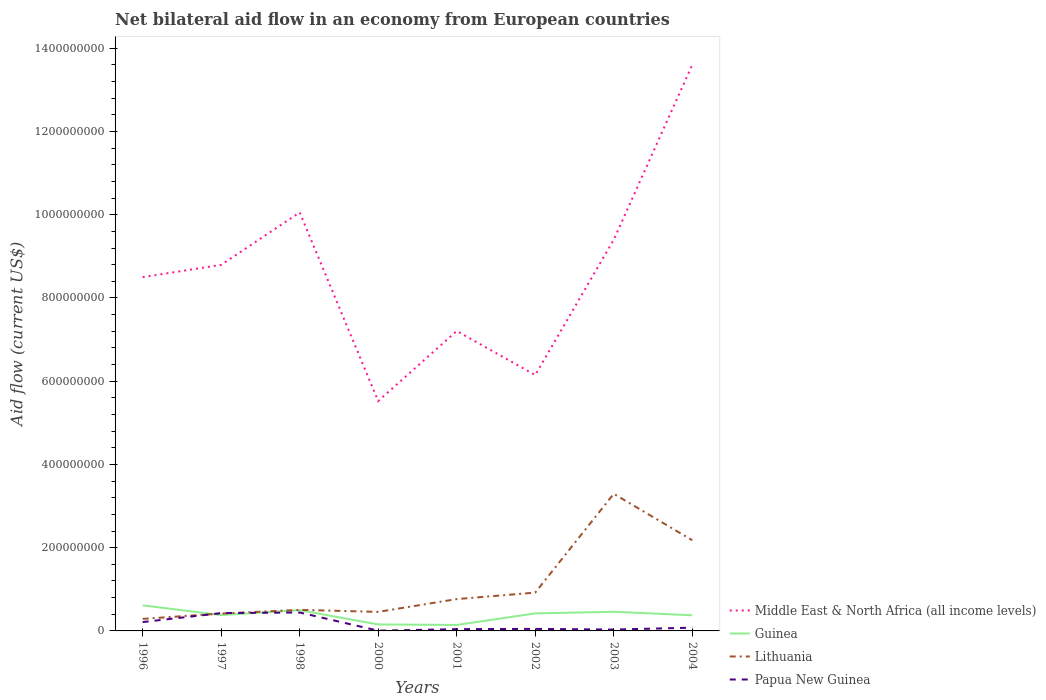Does the line corresponding to Middle East & North Africa (all income levels) intersect with the line corresponding to Guinea?
Give a very brief answer. No. Across all years, what is the maximum net bilateral aid flow in Lithuania?
Offer a terse response. 2.89e+07. What is the total net bilateral aid flow in Guinea in the graph?
Your answer should be compact. -2.20e+07. What is the difference between the highest and the second highest net bilateral aid flow in Middle East & North Africa (all income levels)?
Offer a terse response. 8.08e+08. What is the difference between the highest and the lowest net bilateral aid flow in Papua New Guinea?
Keep it short and to the point. 3. What is the difference between two consecutive major ticks on the Y-axis?
Offer a very short reply. 2.00e+08. Does the graph contain any zero values?
Keep it short and to the point. No. Does the graph contain grids?
Your answer should be compact. No. Where does the legend appear in the graph?
Give a very brief answer. Bottom right. What is the title of the graph?
Provide a succinct answer. Net bilateral aid flow in an economy from European countries. Does "Syrian Arab Republic" appear as one of the legend labels in the graph?
Ensure brevity in your answer.  No. What is the label or title of the X-axis?
Provide a short and direct response. Years. What is the Aid flow (current US$) of Middle East & North Africa (all income levels) in 1996?
Provide a short and direct response. 8.50e+08. What is the Aid flow (current US$) in Guinea in 1996?
Your response must be concise. 6.15e+07. What is the Aid flow (current US$) in Lithuania in 1996?
Offer a terse response. 2.89e+07. What is the Aid flow (current US$) of Papua New Guinea in 1996?
Ensure brevity in your answer.  2.13e+07. What is the Aid flow (current US$) of Middle East & North Africa (all income levels) in 1997?
Offer a very short reply. 8.79e+08. What is the Aid flow (current US$) in Guinea in 1997?
Your answer should be very brief. 3.81e+07. What is the Aid flow (current US$) of Lithuania in 1997?
Provide a short and direct response. 4.17e+07. What is the Aid flow (current US$) of Papua New Guinea in 1997?
Offer a terse response. 4.28e+07. What is the Aid flow (current US$) in Middle East & North Africa (all income levels) in 1998?
Keep it short and to the point. 1.01e+09. What is the Aid flow (current US$) of Guinea in 1998?
Provide a short and direct response. 4.98e+07. What is the Aid flow (current US$) in Lithuania in 1998?
Provide a short and direct response. 5.06e+07. What is the Aid flow (current US$) in Papua New Guinea in 1998?
Provide a short and direct response. 4.43e+07. What is the Aid flow (current US$) in Middle East & North Africa (all income levels) in 2000?
Your answer should be very brief. 5.52e+08. What is the Aid flow (current US$) in Guinea in 2000?
Your response must be concise. 1.56e+07. What is the Aid flow (current US$) of Lithuania in 2000?
Make the answer very short. 4.57e+07. What is the Aid flow (current US$) in Papua New Guinea in 2000?
Your response must be concise. 5.70e+05. What is the Aid flow (current US$) in Middle East & North Africa (all income levels) in 2001?
Give a very brief answer. 7.21e+08. What is the Aid flow (current US$) in Guinea in 2001?
Your answer should be compact. 1.43e+07. What is the Aid flow (current US$) in Lithuania in 2001?
Your answer should be compact. 7.64e+07. What is the Aid flow (current US$) of Papua New Guinea in 2001?
Your response must be concise. 4.30e+06. What is the Aid flow (current US$) in Middle East & North Africa (all income levels) in 2002?
Keep it short and to the point. 6.15e+08. What is the Aid flow (current US$) of Guinea in 2002?
Ensure brevity in your answer.  4.22e+07. What is the Aid flow (current US$) of Lithuania in 2002?
Ensure brevity in your answer.  9.21e+07. What is the Aid flow (current US$) in Papua New Guinea in 2002?
Keep it short and to the point. 4.86e+06. What is the Aid flow (current US$) in Middle East & North Africa (all income levels) in 2003?
Your answer should be compact. 9.40e+08. What is the Aid flow (current US$) of Guinea in 2003?
Give a very brief answer. 4.60e+07. What is the Aid flow (current US$) in Lithuania in 2003?
Give a very brief answer. 3.29e+08. What is the Aid flow (current US$) of Papua New Guinea in 2003?
Provide a succinct answer. 3.27e+06. What is the Aid flow (current US$) of Middle East & North Africa (all income levels) in 2004?
Give a very brief answer. 1.36e+09. What is the Aid flow (current US$) of Guinea in 2004?
Your response must be concise. 3.76e+07. What is the Aid flow (current US$) in Lithuania in 2004?
Offer a terse response. 2.18e+08. What is the Aid flow (current US$) of Papua New Guinea in 2004?
Provide a short and direct response. 7.80e+06. Across all years, what is the maximum Aid flow (current US$) in Middle East & North Africa (all income levels)?
Offer a terse response. 1.36e+09. Across all years, what is the maximum Aid flow (current US$) in Guinea?
Give a very brief answer. 6.15e+07. Across all years, what is the maximum Aid flow (current US$) of Lithuania?
Offer a terse response. 3.29e+08. Across all years, what is the maximum Aid flow (current US$) of Papua New Guinea?
Provide a succinct answer. 4.43e+07. Across all years, what is the minimum Aid flow (current US$) in Middle East & North Africa (all income levels)?
Your response must be concise. 5.52e+08. Across all years, what is the minimum Aid flow (current US$) in Guinea?
Provide a short and direct response. 1.43e+07. Across all years, what is the minimum Aid flow (current US$) in Lithuania?
Offer a very short reply. 2.89e+07. Across all years, what is the minimum Aid flow (current US$) of Papua New Guinea?
Your answer should be very brief. 5.70e+05. What is the total Aid flow (current US$) in Middle East & North Africa (all income levels) in the graph?
Make the answer very short. 6.92e+09. What is the total Aid flow (current US$) in Guinea in the graph?
Provide a succinct answer. 3.05e+08. What is the total Aid flow (current US$) of Lithuania in the graph?
Provide a succinct answer. 8.83e+08. What is the total Aid flow (current US$) in Papua New Guinea in the graph?
Your answer should be very brief. 1.29e+08. What is the difference between the Aid flow (current US$) in Middle East & North Africa (all income levels) in 1996 and that in 1997?
Ensure brevity in your answer.  -2.94e+07. What is the difference between the Aid flow (current US$) of Guinea in 1996 and that in 1997?
Ensure brevity in your answer.  2.34e+07. What is the difference between the Aid flow (current US$) of Lithuania in 1996 and that in 1997?
Provide a succinct answer. -1.28e+07. What is the difference between the Aid flow (current US$) of Papua New Guinea in 1996 and that in 1997?
Your answer should be compact. -2.15e+07. What is the difference between the Aid flow (current US$) in Middle East & North Africa (all income levels) in 1996 and that in 1998?
Ensure brevity in your answer.  -1.55e+08. What is the difference between the Aid flow (current US$) in Guinea in 1996 and that in 1998?
Provide a short and direct response. 1.17e+07. What is the difference between the Aid flow (current US$) in Lithuania in 1996 and that in 1998?
Your answer should be very brief. -2.17e+07. What is the difference between the Aid flow (current US$) of Papua New Guinea in 1996 and that in 1998?
Provide a succinct answer. -2.30e+07. What is the difference between the Aid flow (current US$) of Middle East & North Africa (all income levels) in 1996 and that in 2000?
Ensure brevity in your answer.  2.98e+08. What is the difference between the Aid flow (current US$) in Guinea in 1996 and that in 2000?
Make the answer very short. 4.59e+07. What is the difference between the Aid flow (current US$) in Lithuania in 1996 and that in 2000?
Provide a succinct answer. -1.68e+07. What is the difference between the Aid flow (current US$) of Papua New Guinea in 1996 and that in 2000?
Your response must be concise. 2.07e+07. What is the difference between the Aid flow (current US$) in Middle East & North Africa (all income levels) in 1996 and that in 2001?
Offer a very short reply. 1.29e+08. What is the difference between the Aid flow (current US$) in Guinea in 1996 and that in 2001?
Provide a short and direct response. 4.72e+07. What is the difference between the Aid flow (current US$) of Lithuania in 1996 and that in 2001?
Your response must be concise. -4.75e+07. What is the difference between the Aid flow (current US$) in Papua New Guinea in 1996 and that in 2001?
Your answer should be compact. 1.70e+07. What is the difference between the Aid flow (current US$) in Middle East & North Africa (all income levels) in 1996 and that in 2002?
Offer a very short reply. 2.35e+08. What is the difference between the Aid flow (current US$) in Guinea in 1996 and that in 2002?
Ensure brevity in your answer.  1.93e+07. What is the difference between the Aid flow (current US$) in Lithuania in 1996 and that in 2002?
Keep it short and to the point. -6.32e+07. What is the difference between the Aid flow (current US$) in Papua New Guinea in 1996 and that in 2002?
Ensure brevity in your answer.  1.64e+07. What is the difference between the Aid flow (current US$) of Middle East & North Africa (all income levels) in 1996 and that in 2003?
Your answer should be very brief. -8.99e+07. What is the difference between the Aid flow (current US$) of Guinea in 1996 and that in 2003?
Make the answer very short. 1.55e+07. What is the difference between the Aid flow (current US$) in Lithuania in 1996 and that in 2003?
Offer a very short reply. -3.01e+08. What is the difference between the Aid flow (current US$) in Papua New Guinea in 1996 and that in 2003?
Provide a short and direct response. 1.80e+07. What is the difference between the Aid flow (current US$) in Middle East & North Africa (all income levels) in 1996 and that in 2004?
Provide a short and direct response. -5.10e+08. What is the difference between the Aid flow (current US$) of Guinea in 1996 and that in 2004?
Provide a short and direct response. 2.39e+07. What is the difference between the Aid flow (current US$) of Lithuania in 1996 and that in 2004?
Ensure brevity in your answer.  -1.89e+08. What is the difference between the Aid flow (current US$) in Papua New Guinea in 1996 and that in 2004?
Keep it short and to the point. 1.35e+07. What is the difference between the Aid flow (current US$) in Middle East & North Africa (all income levels) in 1997 and that in 1998?
Offer a terse response. -1.26e+08. What is the difference between the Aid flow (current US$) of Guinea in 1997 and that in 1998?
Your answer should be compact. -1.18e+07. What is the difference between the Aid flow (current US$) in Lithuania in 1997 and that in 1998?
Give a very brief answer. -8.89e+06. What is the difference between the Aid flow (current US$) of Papua New Guinea in 1997 and that in 1998?
Your answer should be compact. -1.47e+06. What is the difference between the Aid flow (current US$) of Middle East & North Africa (all income levels) in 1997 and that in 2000?
Make the answer very short. 3.27e+08. What is the difference between the Aid flow (current US$) in Guinea in 1997 and that in 2000?
Provide a succinct answer. 2.25e+07. What is the difference between the Aid flow (current US$) in Lithuania in 1997 and that in 2000?
Your answer should be very brief. -4.02e+06. What is the difference between the Aid flow (current US$) in Papua New Guinea in 1997 and that in 2000?
Offer a very short reply. 4.22e+07. What is the difference between the Aid flow (current US$) of Middle East & North Africa (all income levels) in 1997 and that in 2001?
Ensure brevity in your answer.  1.59e+08. What is the difference between the Aid flow (current US$) of Guinea in 1997 and that in 2001?
Your answer should be very brief. 2.37e+07. What is the difference between the Aid flow (current US$) in Lithuania in 1997 and that in 2001?
Your answer should be compact. -3.47e+07. What is the difference between the Aid flow (current US$) in Papua New Guinea in 1997 and that in 2001?
Your answer should be very brief. 3.85e+07. What is the difference between the Aid flow (current US$) in Middle East & North Africa (all income levels) in 1997 and that in 2002?
Give a very brief answer. 2.65e+08. What is the difference between the Aid flow (current US$) of Guinea in 1997 and that in 2002?
Make the answer very short. -4.10e+06. What is the difference between the Aid flow (current US$) in Lithuania in 1997 and that in 2002?
Provide a succinct answer. -5.04e+07. What is the difference between the Aid flow (current US$) of Papua New Guinea in 1997 and that in 2002?
Your response must be concise. 3.79e+07. What is the difference between the Aid flow (current US$) in Middle East & North Africa (all income levels) in 1997 and that in 2003?
Ensure brevity in your answer.  -6.05e+07. What is the difference between the Aid flow (current US$) of Guinea in 1997 and that in 2003?
Give a very brief answer. -7.96e+06. What is the difference between the Aid flow (current US$) of Lithuania in 1997 and that in 2003?
Your response must be concise. -2.88e+08. What is the difference between the Aid flow (current US$) of Papua New Guinea in 1997 and that in 2003?
Give a very brief answer. 3.95e+07. What is the difference between the Aid flow (current US$) in Middle East & North Africa (all income levels) in 1997 and that in 2004?
Your response must be concise. -4.81e+08. What is the difference between the Aid flow (current US$) in Guinea in 1997 and that in 2004?
Offer a very short reply. 4.90e+05. What is the difference between the Aid flow (current US$) of Lithuania in 1997 and that in 2004?
Your response must be concise. -1.76e+08. What is the difference between the Aid flow (current US$) in Papua New Guinea in 1997 and that in 2004?
Your response must be concise. 3.50e+07. What is the difference between the Aid flow (current US$) in Middle East & North Africa (all income levels) in 1998 and that in 2000?
Provide a short and direct response. 4.53e+08. What is the difference between the Aid flow (current US$) of Guinea in 1998 and that in 2000?
Give a very brief answer. 3.42e+07. What is the difference between the Aid flow (current US$) of Lithuania in 1998 and that in 2000?
Your response must be concise. 4.87e+06. What is the difference between the Aid flow (current US$) of Papua New Guinea in 1998 and that in 2000?
Your answer should be very brief. 4.37e+07. What is the difference between the Aid flow (current US$) in Middle East & North Africa (all income levels) in 1998 and that in 2001?
Make the answer very short. 2.85e+08. What is the difference between the Aid flow (current US$) of Guinea in 1998 and that in 2001?
Provide a succinct answer. 3.55e+07. What is the difference between the Aid flow (current US$) in Lithuania in 1998 and that in 2001?
Your answer should be very brief. -2.58e+07. What is the difference between the Aid flow (current US$) of Papua New Guinea in 1998 and that in 2001?
Make the answer very short. 4.00e+07. What is the difference between the Aid flow (current US$) of Middle East & North Africa (all income levels) in 1998 and that in 2002?
Your answer should be compact. 3.91e+08. What is the difference between the Aid flow (current US$) of Guinea in 1998 and that in 2002?
Keep it short and to the point. 7.65e+06. What is the difference between the Aid flow (current US$) of Lithuania in 1998 and that in 2002?
Make the answer very short. -4.15e+07. What is the difference between the Aid flow (current US$) in Papua New Guinea in 1998 and that in 2002?
Your answer should be very brief. 3.94e+07. What is the difference between the Aid flow (current US$) of Middle East & North Africa (all income levels) in 1998 and that in 2003?
Give a very brief answer. 6.55e+07. What is the difference between the Aid flow (current US$) of Guinea in 1998 and that in 2003?
Keep it short and to the point. 3.79e+06. What is the difference between the Aid flow (current US$) in Lithuania in 1998 and that in 2003?
Your answer should be compact. -2.79e+08. What is the difference between the Aid flow (current US$) of Papua New Guinea in 1998 and that in 2003?
Your answer should be compact. 4.10e+07. What is the difference between the Aid flow (current US$) of Middle East & North Africa (all income levels) in 1998 and that in 2004?
Your response must be concise. -3.55e+08. What is the difference between the Aid flow (current US$) in Guinea in 1998 and that in 2004?
Your response must be concise. 1.22e+07. What is the difference between the Aid flow (current US$) in Lithuania in 1998 and that in 2004?
Make the answer very short. -1.67e+08. What is the difference between the Aid flow (current US$) of Papua New Guinea in 1998 and that in 2004?
Keep it short and to the point. 3.65e+07. What is the difference between the Aid flow (current US$) of Middle East & North Africa (all income levels) in 2000 and that in 2001?
Offer a terse response. -1.68e+08. What is the difference between the Aid flow (current US$) in Guinea in 2000 and that in 2001?
Provide a succinct answer. 1.24e+06. What is the difference between the Aid flow (current US$) of Lithuania in 2000 and that in 2001?
Keep it short and to the point. -3.07e+07. What is the difference between the Aid flow (current US$) of Papua New Guinea in 2000 and that in 2001?
Provide a short and direct response. -3.73e+06. What is the difference between the Aid flow (current US$) in Middle East & North Africa (all income levels) in 2000 and that in 2002?
Offer a very short reply. -6.25e+07. What is the difference between the Aid flow (current US$) in Guinea in 2000 and that in 2002?
Keep it short and to the point. -2.66e+07. What is the difference between the Aid flow (current US$) of Lithuania in 2000 and that in 2002?
Your answer should be compact. -4.63e+07. What is the difference between the Aid flow (current US$) in Papua New Guinea in 2000 and that in 2002?
Provide a short and direct response. -4.29e+06. What is the difference between the Aid flow (current US$) in Middle East & North Africa (all income levels) in 2000 and that in 2003?
Provide a succinct answer. -3.88e+08. What is the difference between the Aid flow (current US$) in Guinea in 2000 and that in 2003?
Provide a short and direct response. -3.04e+07. What is the difference between the Aid flow (current US$) in Lithuania in 2000 and that in 2003?
Provide a succinct answer. -2.84e+08. What is the difference between the Aid flow (current US$) in Papua New Guinea in 2000 and that in 2003?
Keep it short and to the point. -2.70e+06. What is the difference between the Aid flow (current US$) in Middle East & North Africa (all income levels) in 2000 and that in 2004?
Offer a very short reply. -8.08e+08. What is the difference between the Aid flow (current US$) of Guinea in 2000 and that in 2004?
Your answer should be very brief. -2.20e+07. What is the difference between the Aid flow (current US$) of Lithuania in 2000 and that in 2004?
Offer a terse response. -1.72e+08. What is the difference between the Aid flow (current US$) of Papua New Guinea in 2000 and that in 2004?
Give a very brief answer. -7.23e+06. What is the difference between the Aid flow (current US$) of Middle East & North Africa (all income levels) in 2001 and that in 2002?
Keep it short and to the point. 1.06e+08. What is the difference between the Aid flow (current US$) in Guinea in 2001 and that in 2002?
Your response must be concise. -2.78e+07. What is the difference between the Aid flow (current US$) in Lithuania in 2001 and that in 2002?
Provide a short and direct response. -1.56e+07. What is the difference between the Aid flow (current US$) in Papua New Guinea in 2001 and that in 2002?
Provide a succinct answer. -5.60e+05. What is the difference between the Aid flow (current US$) in Middle East & North Africa (all income levels) in 2001 and that in 2003?
Provide a short and direct response. -2.19e+08. What is the difference between the Aid flow (current US$) in Guinea in 2001 and that in 2003?
Offer a terse response. -3.17e+07. What is the difference between the Aid flow (current US$) of Lithuania in 2001 and that in 2003?
Offer a very short reply. -2.53e+08. What is the difference between the Aid flow (current US$) in Papua New Guinea in 2001 and that in 2003?
Give a very brief answer. 1.03e+06. What is the difference between the Aid flow (current US$) of Middle East & North Africa (all income levels) in 2001 and that in 2004?
Your answer should be very brief. -6.39e+08. What is the difference between the Aid flow (current US$) in Guinea in 2001 and that in 2004?
Ensure brevity in your answer.  -2.32e+07. What is the difference between the Aid flow (current US$) in Lithuania in 2001 and that in 2004?
Your response must be concise. -1.41e+08. What is the difference between the Aid flow (current US$) in Papua New Guinea in 2001 and that in 2004?
Provide a succinct answer. -3.50e+06. What is the difference between the Aid flow (current US$) of Middle East & North Africa (all income levels) in 2002 and that in 2003?
Make the answer very short. -3.25e+08. What is the difference between the Aid flow (current US$) of Guinea in 2002 and that in 2003?
Offer a very short reply. -3.86e+06. What is the difference between the Aid flow (current US$) of Lithuania in 2002 and that in 2003?
Keep it short and to the point. -2.37e+08. What is the difference between the Aid flow (current US$) in Papua New Guinea in 2002 and that in 2003?
Make the answer very short. 1.59e+06. What is the difference between the Aid flow (current US$) in Middle East & North Africa (all income levels) in 2002 and that in 2004?
Make the answer very short. -7.45e+08. What is the difference between the Aid flow (current US$) in Guinea in 2002 and that in 2004?
Your answer should be compact. 4.59e+06. What is the difference between the Aid flow (current US$) in Lithuania in 2002 and that in 2004?
Provide a succinct answer. -1.26e+08. What is the difference between the Aid flow (current US$) of Papua New Guinea in 2002 and that in 2004?
Ensure brevity in your answer.  -2.94e+06. What is the difference between the Aid flow (current US$) of Middle East & North Africa (all income levels) in 2003 and that in 2004?
Offer a terse response. -4.20e+08. What is the difference between the Aid flow (current US$) in Guinea in 2003 and that in 2004?
Offer a very short reply. 8.45e+06. What is the difference between the Aid flow (current US$) in Lithuania in 2003 and that in 2004?
Your answer should be compact. 1.12e+08. What is the difference between the Aid flow (current US$) of Papua New Guinea in 2003 and that in 2004?
Provide a short and direct response. -4.53e+06. What is the difference between the Aid flow (current US$) of Middle East & North Africa (all income levels) in 1996 and the Aid flow (current US$) of Guinea in 1997?
Give a very brief answer. 8.12e+08. What is the difference between the Aid flow (current US$) of Middle East & North Africa (all income levels) in 1996 and the Aid flow (current US$) of Lithuania in 1997?
Your answer should be compact. 8.08e+08. What is the difference between the Aid flow (current US$) of Middle East & North Africa (all income levels) in 1996 and the Aid flow (current US$) of Papua New Guinea in 1997?
Make the answer very short. 8.07e+08. What is the difference between the Aid flow (current US$) of Guinea in 1996 and the Aid flow (current US$) of Lithuania in 1997?
Keep it short and to the point. 1.98e+07. What is the difference between the Aid flow (current US$) in Guinea in 1996 and the Aid flow (current US$) in Papua New Guinea in 1997?
Make the answer very short. 1.87e+07. What is the difference between the Aid flow (current US$) of Lithuania in 1996 and the Aid flow (current US$) of Papua New Guinea in 1997?
Offer a very short reply. -1.39e+07. What is the difference between the Aid flow (current US$) of Middle East & North Africa (all income levels) in 1996 and the Aid flow (current US$) of Guinea in 1998?
Your answer should be compact. 8.00e+08. What is the difference between the Aid flow (current US$) in Middle East & North Africa (all income levels) in 1996 and the Aid flow (current US$) in Lithuania in 1998?
Provide a succinct answer. 7.99e+08. What is the difference between the Aid flow (current US$) in Middle East & North Africa (all income levels) in 1996 and the Aid flow (current US$) in Papua New Guinea in 1998?
Offer a terse response. 8.06e+08. What is the difference between the Aid flow (current US$) in Guinea in 1996 and the Aid flow (current US$) in Lithuania in 1998?
Give a very brief answer. 1.09e+07. What is the difference between the Aid flow (current US$) in Guinea in 1996 and the Aid flow (current US$) in Papua New Guinea in 1998?
Make the answer very short. 1.72e+07. What is the difference between the Aid flow (current US$) of Lithuania in 1996 and the Aid flow (current US$) of Papua New Guinea in 1998?
Offer a very short reply. -1.54e+07. What is the difference between the Aid flow (current US$) of Middle East & North Africa (all income levels) in 1996 and the Aid flow (current US$) of Guinea in 2000?
Provide a succinct answer. 8.34e+08. What is the difference between the Aid flow (current US$) in Middle East & North Africa (all income levels) in 1996 and the Aid flow (current US$) in Lithuania in 2000?
Provide a succinct answer. 8.04e+08. What is the difference between the Aid flow (current US$) in Middle East & North Africa (all income levels) in 1996 and the Aid flow (current US$) in Papua New Guinea in 2000?
Offer a terse response. 8.49e+08. What is the difference between the Aid flow (current US$) in Guinea in 1996 and the Aid flow (current US$) in Lithuania in 2000?
Give a very brief answer. 1.57e+07. What is the difference between the Aid flow (current US$) of Guinea in 1996 and the Aid flow (current US$) of Papua New Guinea in 2000?
Offer a terse response. 6.09e+07. What is the difference between the Aid flow (current US$) of Lithuania in 1996 and the Aid flow (current US$) of Papua New Guinea in 2000?
Keep it short and to the point. 2.84e+07. What is the difference between the Aid flow (current US$) of Middle East & North Africa (all income levels) in 1996 and the Aid flow (current US$) of Guinea in 2001?
Make the answer very short. 8.36e+08. What is the difference between the Aid flow (current US$) in Middle East & North Africa (all income levels) in 1996 and the Aid flow (current US$) in Lithuania in 2001?
Provide a succinct answer. 7.74e+08. What is the difference between the Aid flow (current US$) in Middle East & North Africa (all income levels) in 1996 and the Aid flow (current US$) in Papua New Guinea in 2001?
Your answer should be compact. 8.46e+08. What is the difference between the Aid flow (current US$) of Guinea in 1996 and the Aid flow (current US$) of Lithuania in 2001?
Keep it short and to the point. -1.50e+07. What is the difference between the Aid flow (current US$) of Guinea in 1996 and the Aid flow (current US$) of Papua New Guinea in 2001?
Keep it short and to the point. 5.72e+07. What is the difference between the Aid flow (current US$) in Lithuania in 1996 and the Aid flow (current US$) in Papua New Guinea in 2001?
Give a very brief answer. 2.46e+07. What is the difference between the Aid flow (current US$) of Middle East & North Africa (all income levels) in 1996 and the Aid flow (current US$) of Guinea in 2002?
Your response must be concise. 8.08e+08. What is the difference between the Aid flow (current US$) of Middle East & North Africa (all income levels) in 1996 and the Aid flow (current US$) of Lithuania in 2002?
Give a very brief answer. 7.58e+08. What is the difference between the Aid flow (current US$) of Middle East & North Africa (all income levels) in 1996 and the Aid flow (current US$) of Papua New Guinea in 2002?
Provide a succinct answer. 8.45e+08. What is the difference between the Aid flow (current US$) of Guinea in 1996 and the Aid flow (current US$) of Lithuania in 2002?
Your answer should be compact. -3.06e+07. What is the difference between the Aid flow (current US$) in Guinea in 1996 and the Aid flow (current US$) in Papua New Guinea in 2002?
Your answer should be compact. 5.66e+07. What is the difference between the Aid flow (current US$) in Lithuania in 1996 and the Aid flow (current US$) in Papua New Guinea in 2002?
Make the answer very short. 2.41e+07. What is the difference between the Aid flow (current US$) of Middle East & North Africa (all income levels) in 1996 and the Aid flow (current US$) of Guinea in 2003?
Your answer should be very brief. 8.04e+08. What is the difference between the Aid flow (current US$) of Middle East & North Africa (all income levels) in 1996 and the Aid flow (current US$) of Lithuania in 2003?
Your answer should be compact. 5.21e+08. What is the difference between the Aid flow (current US$) of Middle East & North Africa (all income levels) in 1996 and the Aid flow (current US$) of Papua New Guinea in 2003?
Your answer should be very brief. 8.47e+08. What is the difference between the Aid flow (current US$) of Guinea in 1996 and the Aid flow (current US$) of Lithuania in 2003?
Your response must be concise. -2.68e+08. What is the difference between the Aid flow (current US$) in Guinea in 1996 and the Aid flow (current US$) in Papua New Guinea in 2003?
Your answer should be very brief. 5.82e+07. What is the difference between the Aid flow (current US$) of Lithuania in 1996 and the Aid flow (current US$) of Papua New Guinea in 2003?
Your response must be concise. 2.56e+07. What is the difference between the Aid flow (current US$) of Middle East & North Africa (all income levels) in 1996 and the Aid flow (current US$) of Guinea in 2004?
Offer a terse response. 8.12e+08. What is the difference between the Aid flow (current US$) in Middle East & North Africa (all income levels) in 1996 and the Aid flow (current US$) in Lithuania in 2004?
Keep it short and to the point. 6.32e+08. What is the difference between the Aid flow (current US$) of Middle East & North Africa (all income levels) in 1996 and the Aid flow (current US$) of Papua New Guinea in 2004?
Offer a very short reply. 8.42e+08. What is the difference between the Aid flow (current US$) of Guinea in 1996 and the Aid flow (current US$) of Lithuania in 2004?
Offer a terse response. -1.56e+08. What is the difference between the Aid flow (current US$) of Guinea in 1996 and the Aid flow (current US$) of Papua New Guinea in 2004?
Provide a short and direct response. 5.37e+07. What is the difference between the Aid flow (current US$) in Lithuania in 1996 and the Aid flow (current US$) in Papua New Guinea in 2004?
Your answer should be compact. 2.11e+07. What is the difference between the Aid flow (current US$) of Middle East & North Africa (all income levels) in 1997 and the Aid flow (current US$) of Guinea in 1998?
Keep it short and to the point. 8.30e+08. What is the difference between the Aid flow (current US$) in Middle East & North Africa (all income levels) in 1997 and the Aid flow (current US$) in Lithuania in 1998?
Offer a very short reply. 8.29e+08. What is the difference between the Aid flow (current US$) of Middle East & North Africa (all income levels) in 1997 and the Aid flow (current US$) of Papua New Guinea in 1998?
Keep it short and to the point. 8.35e+08. What is the difference between the Aid flow (current US$) in Guinea in 1997 and the Aid flow (current US$) in Lithuania in 1998?
Provide a short and direct response. -1.26e+07. What is the difference between the Aid flow (current US$) of Guinea in 1997 and the Aid flow (current US$) of Papua New Guinea in 1998?
Keep it short and to the point. -6.21e+06. What is the difference between the Aid flow (current US$) of Lithuania in 1997 and the Aid flow (current US$) of Papua New Guinea in 1998?
Your answer should be compact. -2.55e+06. What is the difference between the Aid flow (current US$) in Middle East & North Africa (all income levels) in 1997 and the Aid flow (current US$) in Guinea in 2000?
Give a very brief answer. 8.64e+08. What is the difference between the Aid flow (current US$) of Middle East & North Africa (all income levels) in 1997 and the Aid flow (current US$) of Lithuania in 2000?
Ensure brevity in your answer.  8.34e+08. What is the difference between the Aid flow (current US$) of Middle East & North Africa (all income levels) in 1997 and the Aid flow (current US$) of Papua New Guinea in 2000?
Your answer should be compact. 8.79e+08. What is the difference between the Aid flow (current US$) of Guinea in 1997 and the Aid flow (current US$) of Lithuania in 2000?
Give a very brief answer. -7.68e+06. What is the difference between the Aid flow (current US$) in Guinea in 1997 and the Aid flow (current US$) in Papua New Guinea in 2000?
Make the answer very short. 3.75e+07. What is the difference between the Aid flow (current US$) of Lithuania in 1997 and the Aid flow (current US$) of Papua New Guinea in 2000?
Offer a terse response. 4.12e+07. What is the difference between the Aid flow (current US$) of Middle East & North Africa (all income levels) in 1997 and the Aid flow (current US$) of Guinea in 2001?
Offer a terse response. 8.65e+08. What is the difference between the Aid flow (current US$) of Middle East & North Africa (all income levels) in 1997 and the Aid flow (current US$) of Lithuania in 2001?
Provide a short and direct response. 8.03e+08. What is the difference between the Aid flow (current US$) of Middle East & North Africa (all income levels) in 1997 and the Aid flow (current US$) of Papua New Guinea in 2001?
Provide a succinct answer. 8.75e+08. What is the difference between the Aid flow (current US$) of Guinea in 1997 and the Aid flow (current US$) of Lithuania in 2001?
Provide a succinct answer. -3.84e+07. What is the difference between the Aid flow (current US$) of Guinea in 1997 and the Aid flow (current US$) of Papua New Guinea in 2001?
Your answer should be compact. 3.38e+07. What is the difference between the Aid flow (current US$) of Lithuania in 1997 and the Aid flow (current US$) of Papua New Guinea in 2001?
Keep it short and to the point. 3.74e+07. What is the difference between the Aid flow (current US$) in Middle East & North Africa (all income levels) in 1997 and the Aid flow (current US$) in Guinea in 2002?
Provide a succinct answer. 8.37e+08. What is the difference between the Aid flow (current US$) in Middle East & North Africa (all income levels) in 1997 and the Aid flow (current US$) in Lithuania in 2002?
Offer a very short reply. 7.87e+08. What is the difference between the Aid flow (current US$) of Middle East & North Africa (all income levels) in 1997 and the Aid flow (current US$) of Papua New Guinea in 2002?
Offer a terse response. 8.75e+08. What is the difference between the Aid flow (current US$) in Guinea in 1997 and the Aid flow (current US$) in Lithuania in 2002?
Your answer should be very brief. -5.40e+07. What is the difference between the Aid flow (current US$) of Guinea in 1997 and the Aid flow (current US$) of Papua New Guinea in 2002?
Keep it short and to the point. 3.32e+07. What is the difference between the Aid flow (current US$) of Lithuania in 1997 and the Aid flow (current US$) of Papua New Guinea in 2002?
Provide a short and direct response. 3.69e+07. What is the difference between the Aid flow (current US$) of Middle East & North Africa (all income levels) in 1997 and the Aid flow (current US$) of Guinea in 2003?
Offer a terse response. 8.33e+08. What is the difference between the Aid flow (current US$) of Middle East & North Africa (all income levels) in 1997 and the Aid flow (current US$) of Lithuania in 2003?
Your answer should be compact. 5.50e+08. What is the difference between the Aid flow (current US$) of Middle East & North Africa (all income levels) in 1997 and the Aid flow (current US$) of Papua New Guinea in 2003?
Give a very brief answer. 8.76e+08. What is the difference between the Aid flow (current US$) of Guinea in 1997 and the Aid flow (current US$) of Lithuania in 2003?
Offer a terse response. -2.91e+08. What is the difference between the Aid flow (current US$) in Guinea in 1997 and the Aid flow (current US$) in Papua New Guinea in 2003?
Keep it short and to the point. 3.48e+07. What is the difference between the Aid flow (current US$) in Lithuania in 1997 and the Aid flow (current US$) in Papua New Guinea in 2003?
Provide a short and direct response. 3.84e+07. What is the difference between the Aid flow (current US$) of Middle East & North Africa (all income levels) in 1997 and the Aid flow (current US$) of Guinea in 2004?
Provide a succinct answer. 8.42e+08. What is the difference between the Aid flow (current US$) of Middle East & North Africa (all income levels) in 1997 and the Aid flow (current US$) of Lithuania in 2004?
Keep it short and to the point. 6.62e+08. What is the difference between the Aid flow (current US$) in Middle East & North Africa (all income levels) in 1997 and the Aid flow (current US$) in Papua New Guinea in 2004?
Make the answer very short. 8.72e+08. What is the difference between the Aid flow (current US$) of Guinea in 1997 and the Aid flow (current US$) of Lithuania in 2004?
Provide a short and direct response. -1.80e+08. What is the difference between the Aid flow (current US$) of Guinea in 1997 and the Aid flow (current US$) of Papua New Guinea in 2004?
Your answer should be compact. 3.03e+07. What is the difference between the Aid flow (current US$) in Lithuania in 1997 and the Aid flow (current US$) in Papua New Guinea in 2004?
Make the answer very short. 3.39e+07. What is the difference between the Aid flow (current US$) of Middle East & North Africa (all income levels) in 1998 and the Aid flow (current US$) of Guinea in 2000?
Provide a succinct answer. 9.90e+08. What is the difference between the Aid flow (current US$) in Middle East & North Africa (all income levels) in 1998 and the Aid flow (current US$) in Lithuania in 2000?
Your answer should be very brief. 9.60e+08. What is the difference between the Aid flow (current US$) of Middle East & North Africa (all income levels) in 1998 and the Aid flow (current US$) of Papua New Guinea in 2000?
Give a very brief answer. 1.00e+09. What is the difference between the Aid flow (current US$) of Guinea in 1998 and the Aid flow (current US$) of Lithuania in 2000?
Your answer should be compact. 4.07e+06. What is the difference between the Aid flow (current US$) of Guinea in 1998 and the Aid flow (current US$) of Papua New Guinea in 2000?
Provide a succinct answer. 4.92e+07. What is the difference between the Aid flow (current US$) in Lithuania in 1998 and the Aid flow (current US$) in Papua New Guinea in 2000?
Your response must be concise. 5.00e+07. What is the difference between the Aid flow (current US$) of Middle East & North Africa (all income levels) in 1998 and the Aid flow (current US$) of Guinea in 2001?
Provide a succinct answer. 9.91e+08. What is the difference between the Aid flow (current US$) in Middle East & North Africa (all income levels) in 1998 and the Aid flow (current US$) in Lithuania in 2001?
Offer a very short reply. 9.29e+08. What is the difference between the Aid flow (current US$) of Middle East & North Africa (all income levels) in 1998 and the Aid flow (current US$) of Papua New Guinea in 2001?
Make the answer very short. 1.00e+09. What is the difference between the Aid flow (current US$) in Guinea in 1998 and the Aid flow (current US$) in Lithuania in 2001?
Your answer should be very brief. -2.66e+07. What is the difference between the Aid flow (current US$) in Guinea in 1998 and the Aid flow (current US$) in Papua New Guinea in 2001?
Your response must be concise. 4.55e+07. What is the difference between the Aid flow (current US$) of Lithuania in 1998 and the Aid flow (current US$) of Papua New Guinea in 2001?
Your response must be concise. 4.63e+07. What is the difference between the Aid flow (current US$) of Middle East & North Africa (all income levels) in 1998 and the Aid flow (current US$) of Guinea in 2002?
Ensure brevity in your answer.  9.63e+08. What is the difference between the Aid flow (current US$) of Middle East & North Africa (all income levels) in 1998 and the Aid flow (current US$) of Lithuania in 2002?
Provide a succinct answer. 9.13e+08. What is the difference between the Aid flow (current US$) in Middle East & North Africa (all income levels) in 1998 and the Aid flow (current US$) in Papua New Guinea in 2002?
Your answer should be very brief. 1.00e+09. What is the difference between the Aid flow (current US$) in Guinea in 1998 and the Aid flow (current US$) in Lithuania in 2002?
Give a very brief answer. -4.23e+07. What is the difference between the Aid flow (current US$) of Guinea in 1998 and the Aid flow (current US$) of Papua New Guinea in 2002?
Keep it short and to the point. 4.50e+07. What is the difference between the Aid flow (current US$) in Lithuania in 1998 and the Aid flow (current US$) in Papua New Guinea in 2002?
Your response must be concise. 4.58e+07. What is the difference between the Aid flow (current US$) in Middle East & North Africa (all income levels) in 1998 and the Aid flow (current US$) in Guinea in 2003?
Make the answer very short. 9.59e+08. What is the difference between the Aid flow (current US$) of Middle East & North Africa (all income levels) in 1998 and the Aid flow (current US$) of Lithuania in 2003?
Your response must be concise. 6.76e+08. What is the difference between the Aid flow (current US$) in Middle East & North Africa (all income levels) in 1998 and the Aid flow (current US$) in Papua New Guinea in 2003?
Provide a short and direct response. 1.00e+09. What is the difference between the Aid flow (current US$) in Guinea in 1998 and the Aid flow (current US$) in Lithuania in 2003?
Make the answer very short. -2.80e+08. What is the difference between the Aid flow (current US$) of Guinea in 1998 and the Aid flow (current US$) of Papua New Guinea in 2003?
Give a very brief answer. 4.65e+07. What is the difference between the Aid flow (current US$) of Lithuania in 1998 and the Aid flow (current US$) of Papua New Guinea in 2003?
Make the answer very short. 4.73e+07. What is the difference between the Aid flow (current US$) in Middle East & North Africa (all income levels) in 1998 and the Aid flow (current US$) in Guinea in 2004?
Offer a terse response. 9.68e+08. What is the difference between the Aid flow (current US$) of Middle East & North Africa (all income levels) in 1998 and the Aid flow (current US$) of Lithuania in 2004?
Offer a very short reply. 7.88e+08. What is the difference between the Aid flow (current US$) in Middle East & North Africa (all income levels) in 1998 and the Aid flow (current US$) in Papua New Guinea in 2004?
Your answer should be compact. 9.98e+08. What is the difference between the Aid flow (current US$) of Guinea in 1998 and the Aid flow (current US$) of Lithuania in 2004?
Your answer should be compact. -1.68e+08. What is the difference between the Aid flow (current US$) of Guinea in 1998 and the Aid flow (current US$) of Papua New Guinea in 2004?
Your answer should be very brief. 4.20e+07. What is the difference between the Aid flow (current US$) in Lithuania in 1998 and the Aid flow (current US$) in Papua New Guinea in 2004?
Offer a very short reply. 4.28e+07. What is the difference between the Aid flow (current US$) of Middle East & North Africa (all income levels) in 2000 and the Aid flow (current US$) of Guinea in 2001?
Keep it short and to the point. 5.38e+08. What is the difference between the Aid flow (current US$) of Middle East & North Africa (all income levels) in 2000 and the Aid flow (current US$) of Lithuania in 2001?
Your answer should be very brief. 4.76e+08. What is the difference between the Aid flow (current US$) of Middle East & North Africa (all income levels) in 2000 and the Aid flow (current US$) of Papua New Guinea in 2001?
Provide a succinct answer. 5.48e+08. What is the difference between the Aid flow (current US$) in Guinea in 2000 and the Aid flow (current US$) in Lithuania in 2001?
Offer a terse response. -6.09e+07. What is the difference between the Aid flow (current US$) in Guinea in 2000 and the Aid flow (current US$) in Papua New Guinea in 2001?
Provide a succinct answer. 1.13e+07. What is the difference between the Aid flow (current US$) of Lithuania in 2000 and the Aid flow (current US$) of Papua New Guinea in 2001?
Offer a very short reply. 4.14e+07. What is the difference between the Aid flow (current US$) of Middle East & North Africa (all income levels) in 2000 and the Aid flow (current US$) of Guinea in 2002?
Provide a succinct answer. 5.10e+08. What is the difference between the Aid flow (current US$) of Middle East & North Africa (all income levels) in 2000 and the Aid flow (current US$) of Lithuania in 2002?
Provide a succinct answer. 4.60e+08. What is the difference between the Aid flow (current US$) in Middle East & North Africa (all income levels) in 2000 and the Aid flow (current US$) in Papua New Guinea in 2002?
Provide a short and direct response. 5.47e+08. What is the difference between the Aid flow (current US$) of Guinea in 2000 and the Aid flow (current US$) of Lithuania in 2002?
Your response must be concise. -7.65e+07. What is the difference between the Aid flow (current US$) in Guinea in 2000 and the Aid flow (current US$) in Papua New Guinea in 2002?
Keep it short and to the point. 1.07e+07. What is the difference between the Aid flow (current US$) in Lithuania in 2000 and the Aid flow (current US$) in Papua New Guinea in 2002?
Keep it short and to the point. 4.09e+07. What is the difference between the Aid flow (current US$) in Middle East & North Africa (all income levels) in 2000 and the Aid flow (current US$) in Guinea in 2003?
Make the answer very short. 5.06e+08. What is the difference between the Aid flow (current US$) in Middle East & North Africa (all income levels) in 2000 and the Aid flow (current US$) in Lithuania in 2003?
Offer a terse response. 2.23e+08. What is the difference between the Aid flow (current US$) of Middle East & North Africa (all income levels) in 2000 and the Aid flow (current US$) of Papua New Guinea in 2003?
Offer a terse response. 5.49e+08. What is the difference between the Aid flow (current US$) in Guinea in 2000 and the Aid flow (current US$) in Lithuania in 2003?
Keep it short and to the point. -3.14e+08. What is the difference between the Aid flow (current US$) in Guinea in 2000 and the Aid flow (current US$) in Papua New Guinea in 2003?
Keep it short and to the point. 1.23e+07. What is the difference between the Aid flow (current US$) in Lithuania in 2000 and the Aid flow (current US$) in Papua New Guinea in 2003?
Provide a short and direct response. 4.25e+07. What is the difference between the Aid flow (current US$) of Middle East & North Africa (all income levels) in 2000 and the Aid flow (current US$) of Guinea in 2004?
Provide a succinct answer. 5.15e+08. What is the difference between the Aid flow (current US$) of Middle East & North Africa (all income levels) in 2000 and the Aid flow (current US$) of Lithuania in 2004?
Ensure brevity in your answer.  3.34e+08. What is the difference between the Aid flow (current US$) in Middle East & North Africa (all income levels) in 2000 and the Aid flow (current US$) in Papua New Guinea in 2004?
Offer a terse response. 5.44e+08. What is the difference between the Aid flow (current US$) in Guinea in 2000 and the Aid flow (current US$) in Lithuania in 2004?
Ensure brevity in your answer.  -2.02e+08. What is the difference between the Aid flow (current US$) in Guinea in 2000 and the Aid flow (current US$) in Papua New Guinea in 2004?
Your response must be concise. 7.77e+06. What is the difference between the Aid flow (current US$) of Lithuania in 2000 and the Aid flow (current US$) of Papua New Guinea in 2004?
Ensure brevity in your answer.  3.79e+07. What is the difference between the Aid flow (current US$) in Middle East & North Africa (all income levels) in 2001 and the Aid flow (current US$) in Guinea in 2002?
Ensure brevity in your answer.  6.78e+08. What is the difference between the Aid flow (current US$) of Middle East & North Africa (all income levels) in 2001 and the Aid flow (current US$) of Lithuania in 2002?
Your response must be concise. 6.29e+08. What is the difference between the Aid flow (current US$) in Middle East & North Africa (all income levels) in 2001 and the Aid flow (current US$) in Papua New Guinea in 2002?
Your response must be concise. 7.16e+08. What is the difference between the Aid flow (current US$) in Guinea in 2001 and the Aid flow (current US$) in Lithuania in 2002?
Your response must be concise. -7.77e+07. What is the difference between the Aid flow (current US$) in Guinea in 2001 and the Aid flow (current US$) in Papua New Guinea in 2002?
Keep it short and to the point. 9.47e+06. What is the difference between the Aid flow (current US$) in Lithuania in 2001 and the Aid flow (current US$) in Papua New Guinea in 2002?
Ensure brevity in your answer.  7.16e+07. What is the difference between the Aid flow (current US$) in Middle East & North Africa (all income levels) in 2001 and the Aid flow (current US$) in Guinea in 2003?
Your answer should be compact. 6.75e+08. What is the difference between the Aid flow (current US$) in Middle East & North Africa (all income levels) in 2001 and the Aid flow (current US$) in Lithuania in 2003?
Offer a terse response. 3.91e+08. What is the difference between the Aid flow (current US$) in Middle East & North Africa (all income levels) in 2001 and the Aid flow (current US$) in Papua New Guinea in 2003?
Your answer should be compact. 7.17e+08. What is the difference between the Aid flow (current US$) in Guinea in 2001 and the Aid flow (current US$) in Lithuania in 2003?
Give a very brief answer. -3.15e+08. What is the difference between the Aid flow (current US$) of Guinea in 2001 and the Aid flow (current US$) of Papua New Guinea in 2003?
Your response must be concise. 1.11e+07. What is the difference between the Aid flow (current US$) in Lithuania in 2001 and the Aid flow (current US$) in Papua New Guinea in 2003?
Offer a very short reply. 7.32e+07. What is the difference between the Aid flow (current US$) in Middle East & North Africa (all income levels) in 2001 and the Aid flow (current US$) in Guinea in 2004?
Offer a terse response. 6.83e+08. What is the difference between the Aid flow (current US$) in Middle East & North Africa (all income levels) in 2001 and the Aid flow (current US$) in Lithuania in 2004?
Give a very brief answer. 5.03e+08. What is the difference between the Aid flow (current US$) in Middle East & North Africa (all income levels) in 2001 and the Aid flow (current US$) in Papua New Guinea in 2004?
Provide a succinct answer. 7.13e+08. What is the difference between the Aid flow (current US$) of Guinea in 2001 and the Aid flow (current US$) of Lithuania in 2004?
Your response must be concise. -2.04e+08. What is the difference between the Aid flow (current US$) of Guinea in 2001 and the Aid flow (current US$) of Papua New Guinea in 2004?
Ensure brevity in your answer.  6.53e+06. What is the difference between the Aid flow (current US$) of Lithuania in 2001 and the Aid flow (current US$) of Papua New Guinea in 2004?
Make the answer very short. 6.86e+07. What is the difference between the Aid flow (current US$) in Middle East & North Africa (all income levels) in 2002 and the Aid flow (current US$) in Guinea in 2003?
Provide a short and direct response. 5.69e+08. What is the difference between the Aid flow (current US$) of Middle East & North Africa (all income levels) in 2002 and the Aid flow (current US$) of Lithuania in 2003?
Your answer should be compact. 2.85e+08. What is the difference between the Aid flow (current US$) of Middle East & North Africa (all income levels) in 2002 and the Aid flow (current US$) of Papua New Guinea in 2003?
Provide a succinct answer. 6.12e+08. What is the difference between the Aid flow (current US$) in Guinea in 2002 and the Aid flow (current US$) in Lithuania in 2003?
Make the answer very short. -2.87e+08. What is the difference between the Aid flow (current US$) in Guinea in 2002 and the Aid flow (current US$) in Papua New Guinea in 2003?
Make the answer very short. 3.89e+07. What is the difference between the Aid flow (current US$) in Lithuania in 2002 and the Aid flow (current US$) in Papua New Guinea in 2003?
Your answer should be compact. 8.88e+07. What is the difference between the Aid flow (current US$) in Middle East & North Africa (all income levels) in 2002 and the Aid flow (current US$) in Guinea in 2004?
Offer a very short reply. 5.77e+08. What is the difference between the Aid flow (current US$) in Middle East & North Africa (all income levels) in 2002 and the Aid flow (current US$) in Lithuania in 2004?
Provide a succinct answer. 3.97e+08. What is the difference between the Aid flow (current US$) of Middle East & North Africa (all income levels) in 2002 and the Aid flow (current US$) of Papua New Guinea in 2004?
Your response must be concise. 6.07e+08. What is the difference between the Aid flow (current US$) of Guinea in 2002 and the Aid flow (current US$) of Lithuania in 2004?
Your answer should be compact. -1.76e+08. What is the difference between the Aid flow (current US$) in Guinea in 2002 and the Aid flow (current US$) in Papua New Guinea in 2004?
Your answer should be compact. 3.44e+07. What is the difference between the Aid flow (current US$) of Lithuania in 2002 and the Aid flow (current US$) of Papua New Guinea in 2004?
Make the answer very short. 8.43e+07. What is the difference between the Aid flow (current US$) of Middle East & North Africa (all income levels) in 2003 and the Aid flow (current US$) of Guinea in 2004?
Your answer should be compact. 9.02e+08. What is the difference between the Aid flow (current US$) in Middle East & North Africa (all income levels) in 2003 and the Aid flow (current US$) in Lithuania in 2004?
Give a very brief answer. 7.22e+08. What is the difference between the Aid flow (current US$) in Middle East & North Africa (all income levels) in 2003 and the Aid flow (current US$) in Papua New Guinea in 2004?
Provide a short and direct response. 9.32e+08. What is the difference between the Aid flow (current US$) of Guinea in 2003 and the Aid flow (current US$) of Lithuania in 2004?
Offer a very short reply. -1.72e+08. What is the difference between the Aid flow (current US$) of Guinea in 2003 and the Aid flow (current US$) of Papua New Guinea in 2004?
Your answer should be very brief. 3.82e+07. What is the difference between the Aid flow (current US$) in Lithuania in 2003 and the Aid flow (current US$) in Papua New Guinea in 2004?
Your response must be concise. 3.22e+08. What is the average Aid flow (current US$) of Middle East & North Africa (all income levels) per year?
Make the answer very short. 8.65e+08. What is the average Aid flow (current US$) in Guinea per year?
Your answer should be very brief. 3.81e+07. What is the average Aid flow (current US$) of Lithuania per year?
Your response must be concise. 1.10e+08. What is the average Aid flow (current US$) of Papua New Guinea per year?
Provide a succinct answer. 1.61e+07. In the year 1996, what is the difference between the Aid flow (current US$) of Middle East & North Africa (all income levels) and Aid flow (current US$) of Guinea?
Your response must be concise. 7.89e+08. In the year 1996, what is the difference between the Aid flow (current US$) of Middle East & North Africa (all income levels) and Aid flow (current US$) of Lithuania?
Keep it short and to the point. 8.21e+08. In the year 1996, what is the difference between the Aid flow (current US$) in Middle East & North Africa (all income levels) and Aid flow (current US$) in Papua New Guinea?
Your answer should be very brief. 8.29e+08. In the year 1996, what is the difference between the Aid flow (current US$) of Guinea and Aid flow (current US$) of Lithuania?
Your answer should be compact. 3.26e+07. In the year 1996, what is the difference between the Aid flow (current US$) of Guinea and Aid flow (current US$) of Papua New Guinea?
Give a very brief answer. 4.02e+07. In the year 1996, what is the difference between the Aid flow (current US$) of Lithuania and Aid flow (current US$) of Papua New Guinea?
Give a very brief answer. 7.65e+06. In the year 1997, what is the difference between the Aid flow (current US$) of Middle East & North Africa (all income levels) and Aid flow (current US$) of Guinea?
Your answer should be very brief. 8.41e+08. In the year 1997, what is the difference between the Aid flow (current US$) in Middle East & North Africa (all income levels) and Aid flow (current US$) in Lithuania?
Make the answer very short. 8.38e+08. In the year 1997, what is the difference between the Aid flow (current US$) of Middle East & North Africa (all income levels) and Aid flow (current US$) of Papua New Guinea?
Offer a terse response. 8.37e+08. In the year 1997, what is the difference between the Aid flow (current US$) in Guinea and Aid flow (current US$) in Lithuania?
Your response must be concise. -3.66e+06. In the year 1997, what is the difference between the Aid flow (current US$) of Guinea and Aid flow (current US$) of Papua New Guinea?
Make the answer very short. -4.74e+06. In the year 1997, what is the difference between the Aid flow (current US$) in Lithuania and Aid flow (current US$) in Papua New Guinea?
Provide a short and direct response. -1.08e+06. In the year 1998, what is the difference between the Aid flow (current US$) in Middle East & North Africa (all income levels) and Aid flow (current US$) in Guinea?
Keep it short and to the point. 9.56e+08. In the year 1998, what is the difference between the Aid flow (current US$) of Middle East & North Africa (all income levels) and Aid flow (current US$) of Lithuania?
Make the answer very short. 9.55e+08. In the year 1998, what is the difference between the Aid flow (current US$) in Middle East & North Africa (all income levels) and Aid flow (current US$) in Papua New Guinea?
Your response must be concise. 9.61e+08. In the year 1998, what is the difference between the Aid flow (current US$) of Guinea and Aid flow (current US$) of Lithuania?
Ensure brevity in your answer.  -8.00e+05. In the year 1998, what is the difference between the Aid flow (current US$) of Guinea and Aid flow (current US$) of Papua New Guinea?
Make the answer very short. 5.54e+06. In the year 1998, what is the difference between the Aid flow (current US$) in Lithuania and Aid flow (current US$) in Papua New Guinea?
Ensure brevity in your answer.  6.34e+06. In the year 2000, what is the difference between the Aid flow (current US$) of Middle East & North Africa (all income levels) and Aid flow (current US$) of Guinea?
Offer a terse response. 5.37e+08. In the year 2000, what is the difference between the Aid flow (current US$) in Middle East & North Africa (all income levels) and Aid flow (current US$) in Lithuania?
Your response must be concise. 5.07e+08. In the year 2000, what is the difference between the Aid flow (current US$) in Middle East & North Africa (all income levels) and Aid flow (current US$) in Papua New Guinea?
Provide a short and direct response. 5.52e+08. In the year 2000, what is the difference between the Aid flow (current US$) of Guinea and Aid flow (current US$) of Lithuania?
Make the answer very short. -3.02e+07. In the year 2000, what is the difference between the Aid flow (current US$) in Guinea and Aid flow (current US$) in Papua New Guinea?
Offer a terse response. 1.50e+07. In the year 2000, what is the difference between the Aid flow (current US$) in Lithuania and Aid flow (current US$) in Papua New Guinea?
Make the answer very short. 4.52e+07. In the year 2001, what is the difference between the Aid flow (current US$) in Middle East & North Africa (all income levels) and Aid flow (current US$) in Guinea?
Provide a short and direct response. 7.06e+08. In the year 2001, what is the difference between the Aid flow (current US$) of Middle East & North Africa (all income levels) and Aid flow (current US$) of Lithuania?
Your answer should be very brief. 6.44e+08. In the year 2001, what is the difference between the Aid flow (current US$) in Middle East & North Africa (all income levels) and Aid flow (current US$) in Papua New Guinea?
Your answer should be very brief. 7.16e+08. In the year 2001, what is the difference between the Aid flow (current US$) in Guinea and Aid flow (current US$) in Lithuania?
Provide a short and direct response. -6.21e+07. In the year 2001, what is the difference between the Aid flow (current US$) of Guinea and Aid flow (current US$) of Papua New Guinea?
Provide a short and direct response. 1.00e+07. In the year 2001, what is the difference between the Aid flow (current US$) in Lithuania and Aid flow (current US$) in Papua New Guinea?
Your answer should be very brief. 7.22e+07. In the year 2002, what is the difference between the Aid flow (current US$) in Middle East & North Africa (all income levels) and Aid flow (current US$) in Guinea?
Offer a very short reply. 5.73e+08. In the year 2002, what is the difference between the Aid flow (current US$) in Middle East & North Africa (all income levels) and Aid flow (current US$) in Lithuania?
Offer a terse response. 5.23e+08. In the year 2002, what is the difference between the Aid flow (current US$) in Middle East & North Africa (all income levels) and Aid flow (current US$) in Papua New Guinea?
Ensure brevity in your answer.  6.10e+08. In the year 2002, what is the difference between the Aid flow (current US$) of Guinea and Aid flow (current US$) of Lithuania?
Give a very brief answer. -4.99e+07. In the year 2002, what is the difference between the Aid flow (current US$) of Guinea and Aid flow (current US$) of Papua New Guinea?
Ensure brevity in your answer.  3.73e+07. In the year 2002, what is the difference between the Aid flow (current US$) in Lithuania and Aid flow (current US$) in Papua New Guinea?
Your answer should be very brief. 8.72e+07. In the year 2003, what is the difference between the Aid flow (current US$) of Middle East & North Africa (all income levels) and Aid flow (current US$) of Guinea?
Your answer should be very brief. 8.94e+08. In the year 2003, what is the difference between the Aid flow (current US$) in Middle East & North Africa (all income levels) and Aid flow (current US$) in Lithuania?
Make the answer very short. 6.10e+08. In the year 2003, what is the difference between the Aid flow (current US$) of Middle East & North Africa (all income levels) and Aid flow (current US$) of Papua New Guinea?
Provide a succinct answer. 9.37e+08. In the year 2003, what is the difference between the Aid flow (current US$) of Guinea and Aid flow (current US$) of Lithuania?
Offer a terse response. -2.83e+08. In the year 2003, what is the difference between the Aid flow (current US$) in Guinea and Aid flow (current US$) in Papua New Guinea?
Offer a very short reply. 4.28e+07. In the year 2003, what is the difference between the Aid flow (current US$) in Lithuania and Aid flow (current US$) in Papua New Guinea?
Keep it short and to the point. 3.26e+08. In the year 2004, what is the difference between the Aid flow (current US$) in Middle East & North Africa (all income levels) and Aid flow (current US$) in Guinea?
Ensure brevity in your answer.  1.32e+09. In the year 2004, what is the difference between the Aid flow (current US$) of Middle East & North Africa (all income levels) and Aid flow (current US$) of Lithuania?
Your answer should be very brief. 1.14e+09. In the year 2004, what is the difference between the Aid flow (current US$) in Middle East & North Africa (all income levels) and Aid flow (current US$) in Papua New Guinea?
Your answer should be very brief. 1.35e+09. In the year 2004, what is the difference between the Aid flow (current US$) in Guinea and Aid flow (current US$) in Lithuania?
Keep it short and to the point. -1.80e+08. In the year 2004, what is the difference between the Aid flow (current US$) in Guinea and Aid flow (current US$) in Papua New Guinea?
Provide a short and direct response. 2.98e+07. In the year 2004, what is the difference between the Aid flow (current US$) of Lithuania and Aid flow (current US$) of Papua New Guinea?
Keep it short and to the point. 2.10e+08. What is the ratio of the Aid flow (current US$) in Middle East & North Africa (all income levels) in 1996 to that in 1997?
Offer a terse response. 0.97. What is the ratio of the Aid flow (current US$) of Guinea in 1996 to that in 1997?
Make the answer very short. 1.62. What is the ratio of the Aid flow (current US$) of Lithuania in 1996 to that in 1997?
Give a very brief answer. 0.69. What is the ratio of the Aid flow (current US$) of Papua New Guinea in 1996 to that in 1997?
Your response must be concise. 0.5. What is the ratio of the Aid flow (current US$) of Middle East & North Africa (all income levels) in 1996 to that in 1998?
Keep it short and to the point. 0.85. What is the ratio of the Aid flow (current US$) in Guinea in 1996 to that in 1998?
Your response must be concise. 1.23. What is the ratio of the Aid flow (current US$) of Lithuania in 1996 to that in 1998?
Offer a very short reply. 0.57. What is the ratio of the Aid flow (current US$) in Papua New Guinea in 1996 to that in 1998?
Offer a very short reply. 0.48. What is the ratio of the Aid flow (current US$) of Middle East & North Africa (all income levels) in 1996 to that in 2000?
Make the answer very short. 1.54. What is the ratio of the Aid flow (current US$) of Guinea in 1996 to that in 2000?
Provide a succinct answer. 3.95. What is the ratio of the Aid flow (current US$) in Lithuania in 1996 to that in 2000?
Your answer should be very brief. 0.63. What is the ratio of the Aid flow (current US$) of Papua New Guinea in 1996 to that in 2000?
Offer a terse response. 37.32. What is the ratio of the Aid flow (current US$) in Middle East & North Africa (all income levels) in 1996 to that in 2001?
Keep it short and to the point. 1.18. What is the ratio of the Aid flow (current US$) of Guinea in 1996 to that in 2001?
Offer a terse response. 4.29. What is the ratio of the Aid flow (current US$) in Lithuania in 1996 to that in 2001?
Offer a terse response. 0.38. What is the ratio of the Aid flow (current US$) in Papua New Guinea in 1996 to that in 2001?
Offer a terse response. 4.95. What is the ratio of the Aid flow (current US$) of Middle East & North Africa (all income levels) in 1996 to that in 2002?
Provide a succinct answer. 1.38. What is the ratio of the Aid flow (current US$) in Guinea in 1996 to that in 2002?
Offer a very short reply. 1.46. What is the ratio of the Aid flow (current US$) of Lithuania in 1996 to that in 2002?
Give a very brief answer. 0.31. What is the ratio of the Aid flow (current US$) in Papua New Guinea in 1996 to that in 2002?
Give a very brief answer. 4.38. What is the ratio of the Aid flow (current US$) in Middle East & North Africa (all income levels) in 1996 to that in 2003?
Give a very brief answer. 0.9. What is the ratio of the Aid flow (current US$) in Guinea in 1996 to that in 2003?
Give a very brief answer. 1.34. What is the ratio of the Aid flow (current US$) in Lithuania in 1996 to that in 2003?
Make the answer very short. 0.09. What is the ratio of the Aid flow (current US$) in Papua New Guinea in 1996 to that in 2003?
Your response must be concise. 6.5. What is the ratio of the Aid flow (current US$) of Middle East & North Africa (all income levels) in 1996 to that in 2004?
Make the answer very short. 0.62. What is the ratio of the Aid flow (current US$) in Guinea in 1996 to that in 2004?
Your response must be concise. 1.64. What is the ratio of the Aid flow (current US$) in Lithuania in 1996 to that in 2004?
Your response must be concise. 0.13. What is the ratio of the Aid flow (current US$) in Papua New Guinea in 1996 to that in 2004?
Provide a succinct answer. 2.73. What is the ratio of the Aid flow (current US$) in Middle East & North Africa (all income levels) in 1997 to that in 1998?
Your answer should be compact. 0.87. What is the ratio of the Aid flow (current US$) in Guinea in 1997 to that in 1998?
Keep it short and to the point. 0.76. What is the ratio of the Aid flow (current US$) in Lithuania in 1997 to that in 1998?
Make the answer very short. 0.82. What is the ratio of the Aid flow (current US$) in Papua New Guinea in 1997 to that in 1998?
Provide a succinct answer. 0.97. What is the ratio of the Aid flow (current US$) in Middle East & North Africa (all income levels) in 1997 to that in 2000?
Offer a very short reply. 1.59. What is the ratio of the Aid flow (current US$) of Guinea in 1997 to that in 2000?
Your response must be concise. 2.44. What is the ratio of the Aid flow (current US$) of Lithuania in 1997 to that in 2000?
Your answer should be very brief. 0.91. What is the ratio of the Aid flow (current US$) in Papua New Guinea in 1997 to that in 2000?
Your answer should be compact. 75.09. What is the ratio of the Aid flow (current US$) in Middle East & North Africa (all income levels) in 1997 to that in 2001?
Your answer should be compact. 1.22. What is the ratio of the Aid flow (current US$) of Guinea in 1997 to that in 2001?
Offer a very short reply. 2.66. What is the ratio of the Aid flow (current US$) of Lithuania in 1997 to that in 2001?
Provide a succinct answer. 0.55. What is the ratio of the Aid flow (current US$) of Papua New Guinea in 1997 to that in 2001?
Offer a terse response. 9.95. What is the ratio of the Aid flow (current US$) of Middle East & North Africa (all income levels) in 1997 to that in 2002?
Provide a succinct answer. 1.43. What is the ratio of the Aid flow (current US$) of Guinea in 1997 to that in 2002?
Your response must be concise. 0.9. What is the ratio of the Aid flow (current US$) in Lithuania in 1997 to that in 2002?
Offer a very short reply. 0.45. What is the ratio of the Aid flow (current US$) in Papua New Guinea in 1997 to that in 2002?
Your answer should be very brief. 8.81. What is the ratio of the Aid flow (current US$) of Middle East & North Africa (all income levels) in 1997 to that in 2003?
Ensure brevity in your answer.  0.94. What is the ratio of the Aid flow (current US$) of Guinea in 1997 to that in 2003?
Provide a succinct answer. 0.83. What is the ratio of the Aid flow (current US$) in Lithuania in 1997 to that in 2003?
Provide a short and direct response. 0.13. What is the ratio of the Aid flow (current US$) in Papua New Guinea in 1997 to that in 2003?
Your response must be concise. 13.09. What is the ratio of the Aid flow (current US$) in Middle East & North Africa (all income levels) in 1997 to that in 2004?
Your answer should be compact. 0.65. What is the ratio of the Aid flow (current US$) of Guinea in 1997 to that in 2004?
Ensure brevity in your answer.  1.01. What is the ratio of the Aid flow (current US$) of Lithuania in 1997 to that in 2004?
Provide a succinct answer. 0.19. What is the ratio of the Aid flow (current US$) of Papua New Guinea in 1997 to that in 2004?
Your answer should be very brief. 5.49. What is the ratio of the Aid flow (current US$) in Middle East & North Africa (all income levels) in 1998 to that in 2000?
Offer a terse response. 1.82. What is the ratio of the Aid flow (current US$) in Guinea in 1998 to that in 2000?
Make the answer very short. 3.2. What is the ratio of the Aid flow (current US$) in Lithuania in 1998 to that in 2000?
Provide a short and direct response. 1.11. What is the ratio of the Aid flow (current US$) in Papua New Guinea in 1998 to that in 2000?
Offer a terse response. 77.67. What is the ratio of the Aid flow (current US$) of Middle East & North Africa (all income levels) in 1998 to that in 2001?
Offer a terse response. 1.4. What is the ratio of the Aid flow (current US$) of Guinea in 1998 to that in 2001?
Offer a terse response. 3.48. What is the ratio of the Aid flow (current US$) of Lithuania in 1998 to that in 2001?
Your response must be concise. 0.66. What is the ratio of the Aid flow (current US$) in Papua New Guinea in 1998 to that in 2001?
Your response must be concise. 10.3. What is the ratio of the Aid flow (current US$) in Middle East & North Africa (all income levels) in 1998 to that in 2002?
Give a very brief answer. 1.64. What is the ratio of the Aid flow (current US$) in Guinea in 1998 to that in 2002?
Provide a succinct answer. 1.18. What is the ratio of the Aid flow (current US$) in Lithuania in 1998 to that in 2002?
Your answer should be very brief. 0.55. What is the ratio of the Aid flow (current US$) of Papua New Guinea in 1998 to that in 2002?
Your response must be concise. 9.11. What is the ratio of the Aid flow (current US$) of Middle East & North Africa (all income levels) in 1998 to that in 2003?
Ensure brevity in your answer.  1.07. What is the ratio of the Aid flow (current US$) of Guinea in 1998 to that in 2003?
Ensure brevity in your answer.  1.08. What is the ratio of the Aid flow (current US$) in Lithuania in 1998 to that in 2003?
Give a very brief answer. 0.15. What is the ratio of the Aid flow (current US$) in Papua New Guinea in 1998 to that in 2003?
Provide a succinct answer. 13.54. What is the ratio of the Aid flow (current US$) in Middle East & North Africa (all income levels) in 1998 to that in 2004?
Keep it short and to the point. 0.74. What is the ratio of the Aid flow (current US$) in Guinea in 1998 to that in 2004?
Offer a very short reply. 1.33. What is the ratio of the Aid flow (current US$) of Lithuania in 1998 to that in 2004?
Your answer should be very brief. 0.23. What is the ratio of the Aid flow (current US$) in Papua New Guinea in 1998 to that in 2004?
Offer a terse response. 5.68. What is the ratio of the Aid flow (current US$) in Middle East & North Africa (all income levels) in 2000 to that in 2001?
Make the answer very short. 0.77. What is the ratio of the Aid flow (current US$) in Guinea in 2000 to that in 2001?
Your answer should be very brief. 1.09. What is the ratio of the Aid flow (current US$) in Lithuania in 2000 to that in 2001?
Your response must be concise. 0.6. What is the ratio of the Aid flow (current US$) in Papua New Guinea in 2000 to that in 2001?
Offer a terse response. 0.13. What is the ratio of the Aid flow (current US$) of Middle East & North Africa (all income levels) in 2000 to that in 2002?
Offer a very short reply. 0.9. What is the ratio of the Aid flow (current US$) in Guinea in 2000 to that in 2002?
Offer a terse response. 0.37. What is the ratio of the Aid flow (current US$) in Lithuania in 2000 to that in 2002?
Give a very brief answer. 0.5. What is the ratio of the Aid flow (current US$) in Papua New Guinea in 2000 to that in 2002?
Provide a short and direct response. 0.12. What is the ratio of the Aid flow (current US$) of Middle East & North Africa (all income levels) in 2000 to that in 2003?
Your response must be concise. 0.59. What is the ratio of the Aid flow (current US$) of Guinea in 2000 to that in 2003?
Your answer should be compact. 0.34. What is the ratio of the Aid flow (current US$) in Lithuania in 2000 to that in 2003?
Provide a succinct answer. 0.14. What is the ratio of the Aid flow (current US$) in Papua New Guinea in 2000 to that in 2003?
Your response must be concise. 0.17. What is the ratio of the Aid flow (current US$) of Middle East & North Africa (all income levels) in 2000 to that in 2004?
Provide a succinct answer. 0.41. What is the ratio of the Aid flow (current US$) of Guinea in 2000 to that in 2004?
Offer a very short reply. 0.41. What is the ratio of the Aid flow (current US$) in Lithuania in 2000 to that in 2004?
Give a very brief answer. 0.21. What is the ratio of the Aid flow (current US$) in Papua New Guinea in 2000 to that in 2004?
Your response must be concise. 0.07. What is the ratio of the Aid flow (current US$) of Middle East & North Africa (all income levels) in 2001 to that in 2002?
Ensure brevity in your answer.  1.17. What is the ratio of the Aid flow (current US$) in Guinea in 2001 to that in 2002?
Your response must be concise. 0.34. What is the ratio of the Aid flow (current US$) of Lithuania in 2001 to that in 2002?
Keep it short and to the point. 0.83. What is the ratio of the Aid flow (current US$) in Papua New Guinea in 2001 to that in 2002?
Offer a very short reply. 0.88. What is the ratio of the Aid flow (current US$) in Middle East & North Africa (all income levels) in 2001 to that in 2003?
Ensure brevity in your answer.  0.77. What is the ratio of the Aid flow (current US$) of Guinea in 2001 to that in 2003?
Your answer should be compact. 0.31. What is the ratio of the Aid flow (current US$) in Lithuania in 2001 to that in 2003?
Offer a terse response. 0.23. What is the ratio of the Aid flow (current US$) in Papua New Guinea in 2001 to that in 2003?
Ensure brevity in your answer.  1.31. What is the ratio of the Aid flow (current US$) in Middle East & North Africa (all income levels) in 2001 to that in 2004?
Your response must be concise. 0.53. What is the ratio of the Aid flow (current US$) in Guinea in 2001 to that in 2004?
Keep it short and to the point. 0.38. What is the ratio of the Aid flow (current US$) in Lithuania in 2001 to that in 2004?
Offer a very short reply. 0.35. What is the ratio of the Aid flow (current US$) of Papua New Guinea in 2001 to that in 2004?
Make the answer very short. 0.55. What is the ratio of the Aid flow (current US$) in Middle East & North Africa (all income levels) in 2002 to that in 2003?
Provide a short and direct response. 0.65. What is the ratio of the Aid flow (current US$) of Guinea in 2002 to that in 2003?
Your response must be concise. 0.92. What is the ratio of the Aid flow (current US$) in Lithuania in 2002 to that in 2003?
Give a very brief answer. 0.28. What is the ratio of the Aid flow (current US$) in Papua New Guinea in 2002 to that in 2003?
Ensure brevity in your answer.  1.49. What is the ratio of the Aid flow (current US$) in Middle East & North Africa (all income levels) in 2002 to that in 2004?
Provide a succinct answer. 0.45. What is the ratio of the Aid flow (current US$) in Guinea in 2002 to that in 2004?
Ensure brevity in your answer.  1.12. What is the ratio of the Aid flow (current US$) in Lithuania in 2002 to that in 2004?
Offer a terse response. 0.42. What is the ratio of the Aid flow (current US$) in Papua New Guinea in 2002 to that in 2004?
Your response must be concise. 0.62. What is the ratio of the Aid flow (current US$) of Middle East & North Africa (all income levels) in 2003 to that in 2004?
Keep it short and to the point. 0.69. What is the ratio of the Aid flow (current US$) in Guinea in 2003 to that in 2004?
Your answer should be very brief. 1.22. What is the ratio of the Aid flow (current US$) of Lithuania in 2003 to that in 2004?
Offer a very short reply. 1.51. What is the ratio of the Aid flow (current US$) in Papua New Guinea in 2003 to that in 2004?
Ensure brevity in your answer.  0.42. What is the difference between the highest and the second highest Aid flow (current US$) of Middle East & North Africa (all income levels)?
Your answer should be very brief. 3.55e+08. What is the difference between the highest and the second highest Aid flow (current US$) in Guinea?
Make the answer very short. 1.17e+07. What is the difference between the highest and the second highest Aid flow (current US$) of Lithuania?
Offer a terse response. 1.12e+08. What is the difference between the highest and the second highest Aid flow (current US$) of Papua New Guinea?
Ensure brevity in your answer.  1.47e+06. What is the difference between the highest and the lowest Aid flow (current US$) in Middle East & North Africa (all income levels)?
Ensure brevity in your answer.  8.08e+08. What is the difference between the highest and the lowest Aid flow (current US$) of Guinea?
Provide a succinct answer. 4.72e+07. What is the difference between the highest and the lowest Aid flow (current US$) of Lithuania?
Ensure brevity in your answer.  3.01e+08. What is the difference between the highest and the lowest Aid flow (current US$) of Papua New Guinea?
Your response must be concise. 4.37e+07. 